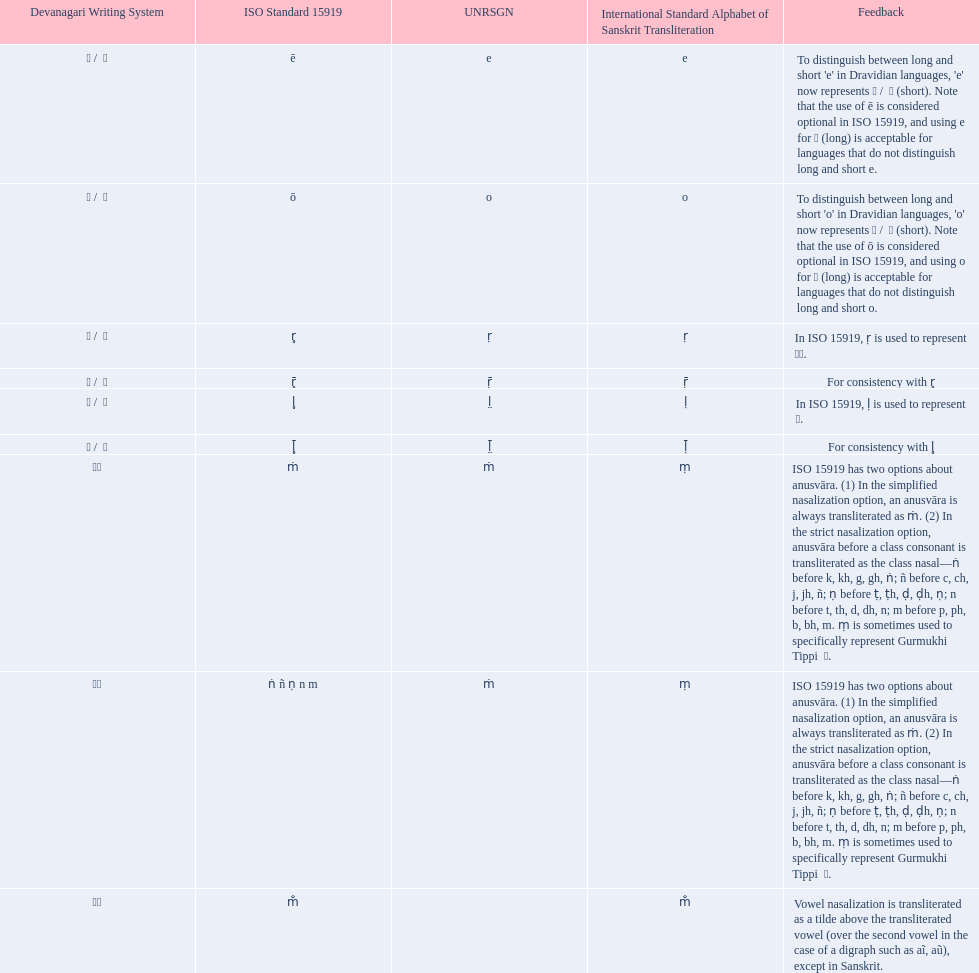Which devanagaria means the same as this iast letter: o? ओ / ो. 